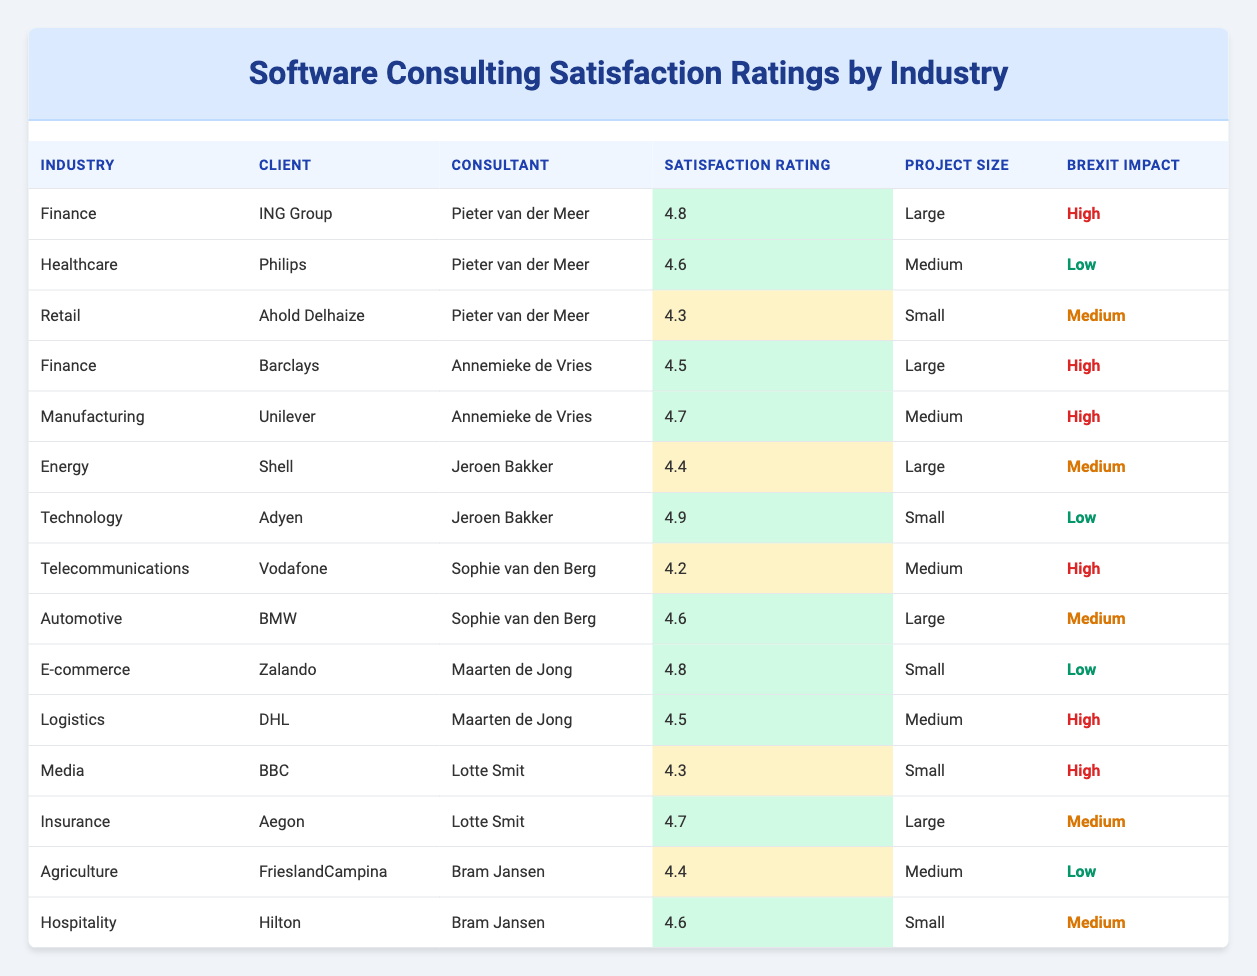What is the highest satisfaction rating in the table? The highest satisfaction rating in the table is found by scanning the "Satisfaction Rating" column. The maximum value listed is 4.9, which corresponds to the consultant Jeroen Bakker from the Technology industry working with the client Adyen.
Answer: 4.9 Which industry has the lowest satisfaction rating? To find the industry with the lowest satisfaction rating, look through the "Satisfaction Rating" column. The lowest rating present is 4.2, associated with the Telecommunications industry and the client Vodafone.
Answer: Telecommunications Is there a client in the Manufacturing industry with a satisfaction rating of 4.7? Checking the table, the Manufacturing industry has one client, Unilever, with a satisfaction rating of 4.7. Therefore, this statement is true.
Answer: Yes How many clients have a 'High' Brexit impact rating? To answer this, count the number of rows in the table where the "Brexit Impact" column states "High." The relevant rows are those related to ING Group, Barclays, Unilever, Vodafone, DHL, BBC, and Hilton, which adds up to a total of 6 clients.
Answer: 6 What is the average satisfaction rating for clients with 'Medium' project size? Identify clients with a "Medium" project size and gather their satisfaction ratings: Philips (4.6), Unilever (4.7), DHL (4.5), and Vodafone (4.2). The average is (4.6 + 4.7 + 4.5 + 4.2) / 4 = 4.525.
Answer: 4.525 Is the satisfaction rating for Ahold Delhaize higher than that for Shell? First, find the satisfaction rating for Ahold Delhaize, which is 4.3, and then for Shell, which is 4.4. Since 4.3 is not greater than 4.4, this statement is false.
Answer: No Which consultant has the most clients listed in the table? To determine this, scan the "Consultant" column and count the number of unique clients for each consultant. Pieter van der Meer has three clients (ING Group, Philips, Ahold Delhaize), Annemieke de Vries has two, Maarten de Jong has two, Jeroen Bakker has two, Lotte Smit has two, and Bram Jansen has two. Thus, Pieter van der Meer has the most clients.
Answer: Pieter van der Meer What is the difference in satisfaction ratings between the highest-rated and lowest-rated consultants? Identify the highest rating (4.9 for Jeroen Bakker) and the lowest rating (4.2 for Sophie van den Berg). The difference is 4.9 - 4.2 = 0.7.
Answer: 0.7 